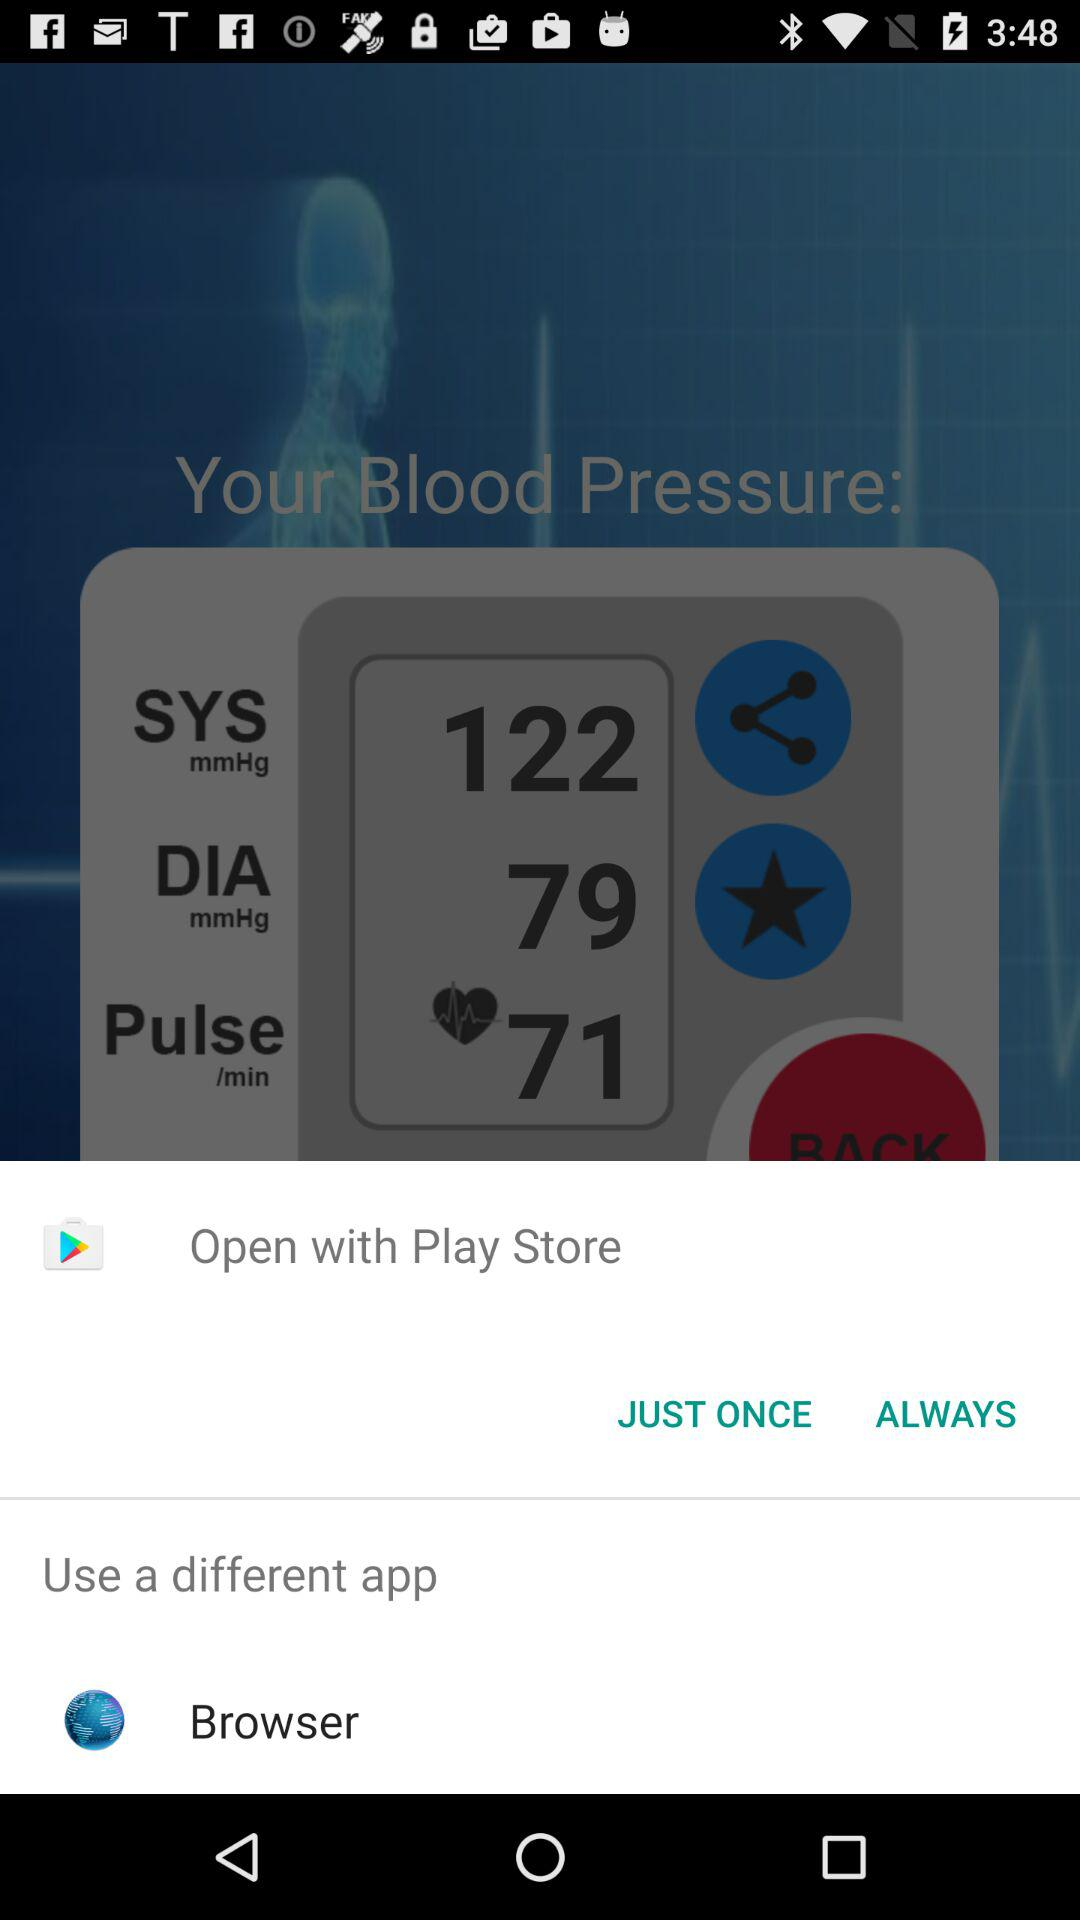What applications can I use to view the content? You can use "Play Store" and "Browser". 